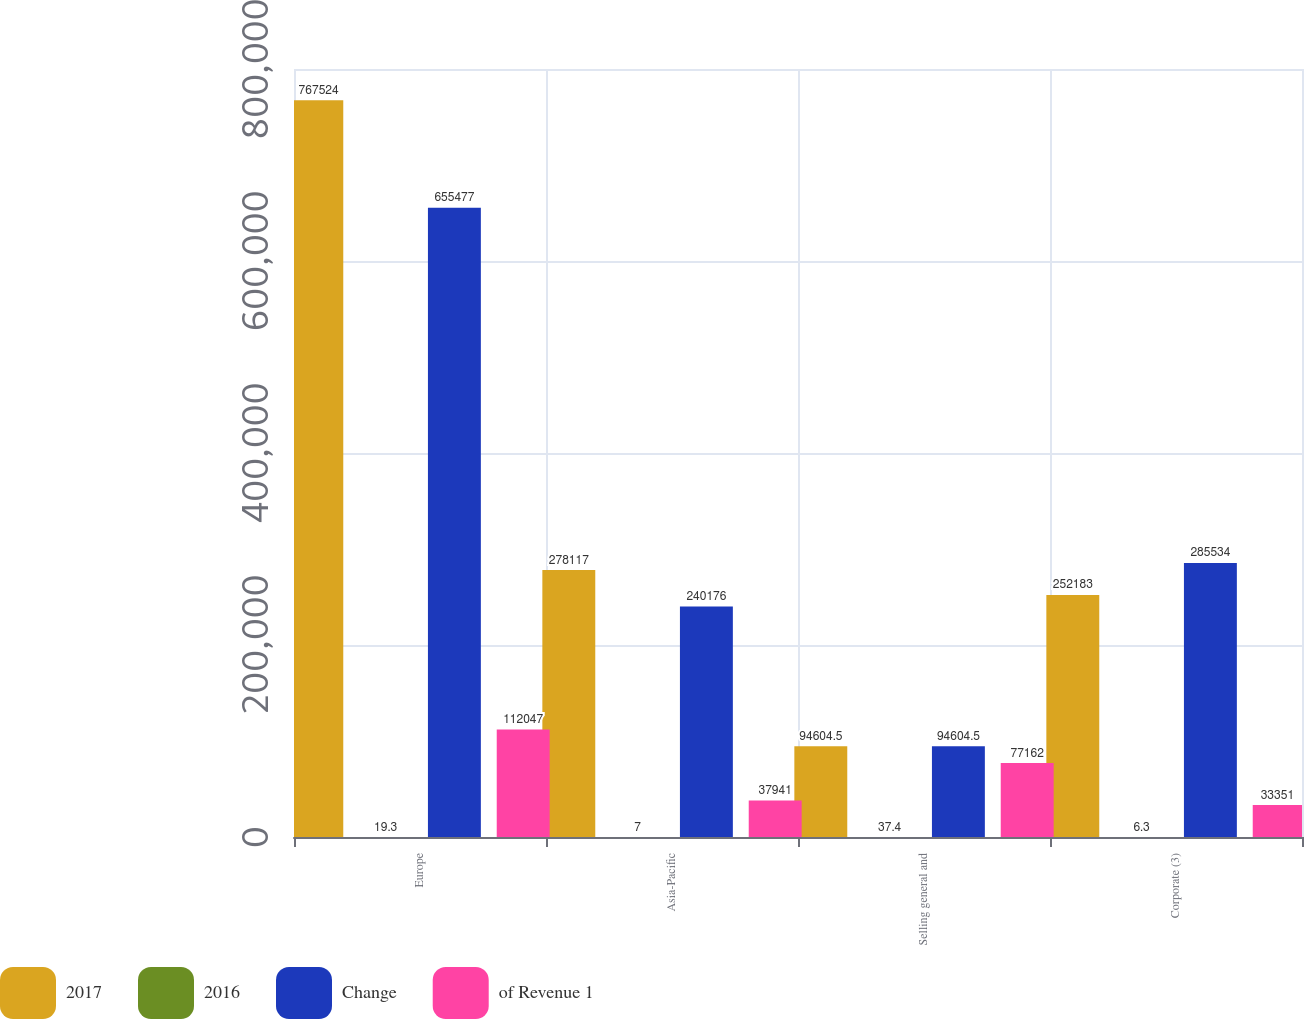<chart> <loc_0><loc_0><loc_500><loc_500><stacked_bar_chart><ecel><fcel>Europe<fcel>Asia-Pacific<fcel>Selling general and<fcel>Corporate (3)<nl><fcel>2017<fcel>767524<fcel>278117<fcel>94604.5<fcel>252183<nl><fcel>2016<fcel>19.3<fcel>7<fcel>37.4<fcel>6.3<nl><fcel>Change<fcel>655477<fcel>240176<fcel>94604.5<fcel>285534<nl><fcel>of Revenue 1<fcel>112047<fcel>37941<fcel>77162<fcel>33351<nl></chart> 